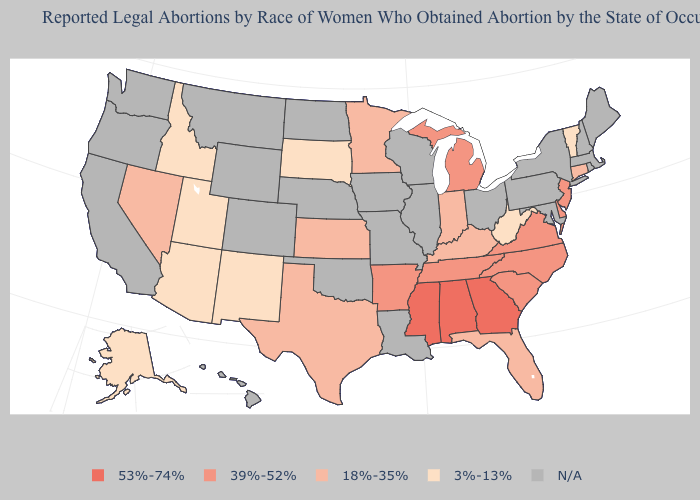Which states hav the highest value in the MidWest?
Quick response, please. Michigan. Among the states that border Virginia , does Tennessee have the lowest value?
Quick response, please. No. Name the states that have a value in the range N/A?
Keep it brief. California, Colorado, Hawaii, Illinois, Iowa, Louisiana, Maine, Maryland, Massachusetts, Missouri, Montana, Nebraska, New Hampshire, New York, North Dakota, Ohio, Oklahoma, Oregon, Pennsylvania, Rhode Island, Washington, Wisconsin, Wyoming. What is the value of Montana?
Short answer required. N/A. Among the states that border Nebraska , does South Dakota have the lowest value?
Quick response, please. Yes. What is the value of South Carolina?
Concise answer only. 39%-52%. Does the first symbol in the legend represent the smallest category?
Be succinct. No. Is the legend a continuous bar?
Write a very short answer. No. What is the value of Indiana?
Concise answer only. 18%-35%. What is the highest value in the Northeast ?
Short answer required. 39%-52%. Which states have the lowest value in the USA?
Short answer required. Alaska, Arizona, Idaho, New Mexico, South Dakota, Utah, Vermont, West Virginia. How many symbols are there in the legend?
Keep it brief. 5. What is the lowest value in states that border Washington?
Concise answer only. 3%-13%. Name the states that have a value in the range 18%-35%?
Keep it brief. Connecticut, Florida, Indiana, Kansas, Kentucky, Minnesota, Nevada, Texas. What is the value of New Jersey?
Give a very brief answer. 39%-52%. 